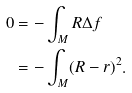Convert formula to latex. <formula><loc_0><loc_0><loc_500><loc_500>0 & = - \int _ { M } R \Delta f \\ & = - \int _ { M } ( R - r ) ^ { 2 } .</formula> 